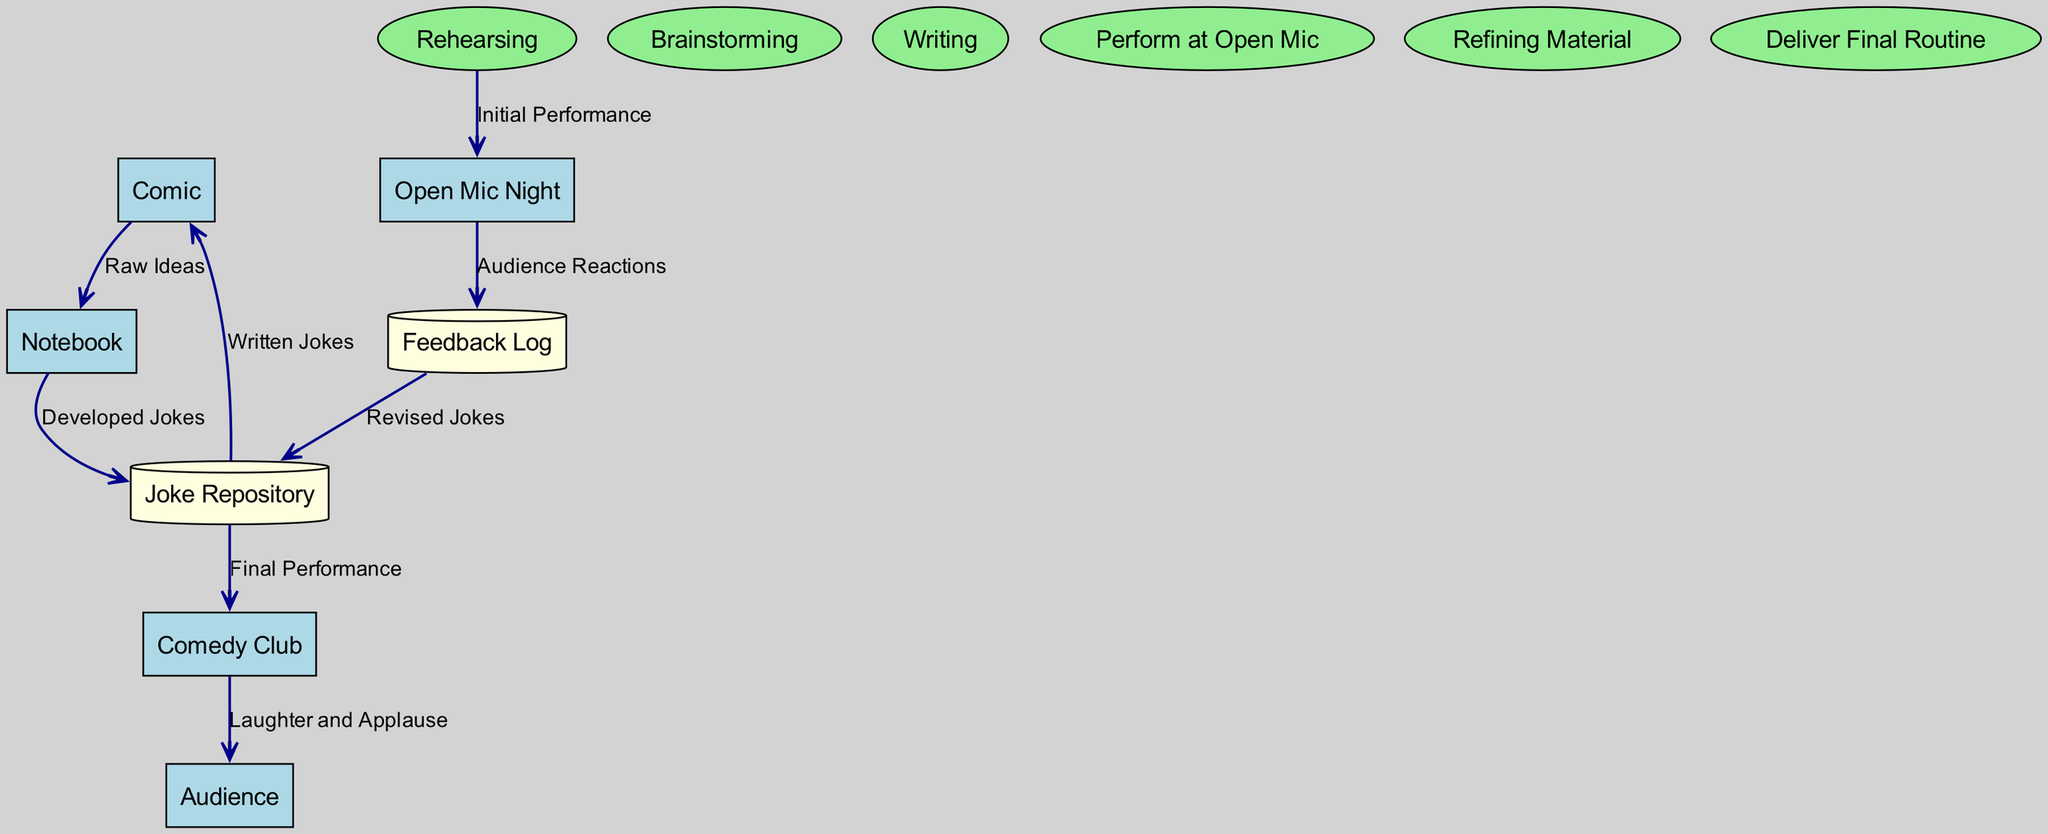What is the first step in the stand-up routine process? The first step indicated in the diagram is "Brainstorming," which involves generating and noting down initial ideas for the routine.
Answer: Brainstorming How many data stores are represented in the diagram? There are two data stores represented: "Joke Repository" and "Feedback Log." Thus, by counting those items, the answer is two.
Answer: Two What is the output data from the "Comedy Club" process? The output from the "Comedy Club" process is "Laughter and Applause," which indicates the audience's reaction to the performance.
Answer: Laughter and Applause Which node receives feedback from "Open Mic Night"? The node that receives feedback is "Feedback Log," where audience reactions are stored for refinement.
Answer: Feedback Log What type of node is "Notebook"? "Notebook" is categorized as an entity in the diagram and has a rectangular shape, indicating that it serves as a physical or digital space for idea collection.
Answer: Entity What data flows from "Feedback Log" to "Joke Repository"? The data that flows is "Revised Jokes," which shows how the comic updates their material based on the feedback collected.
Answer: Revised Jokes Which process involves actual performance in front of an audience? The process that involves performing in front of an audience is "Perform at Open Mic," where the comic tests the material live.
Answer: Perform at Open Mic How does material get refined in the stand-up routine process? Material is refined by taking feedback from the "Open Mic Night," which is logged in the "Feedback Log," and then these notes lead to updates in the "Joke Repository."
Answer: Feedback Log What is the final output of the stand-up routine flow? The final output is labeled "Laughter and Applause," which signifies the successful reception of the stand-up routine by the audience.
Answer: Laughter and Applause 